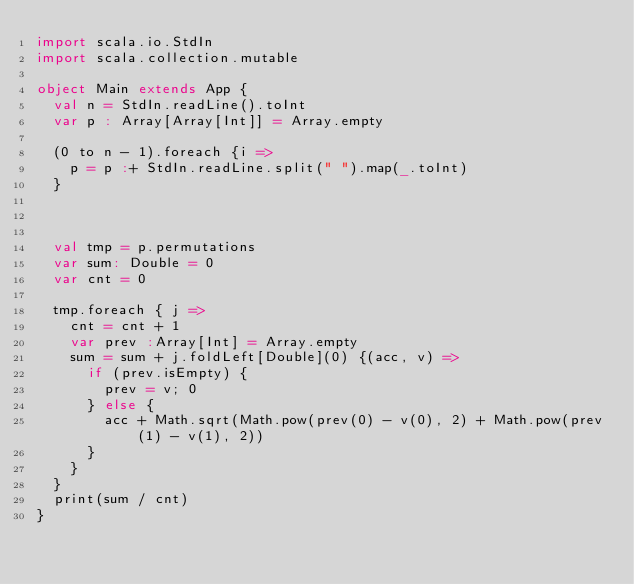<code> <loc_0><loc_0><loc_500><loc_500><_Scala_>import scala.io.StdIn
import scala.collection.mutable

object Main extends App {
  val n = StdIn.readLine().toInt
  var p : Array[Array[Int]] = Array.empty

  (0 to n - 1).foreach {i =>
    p = p :+ StdIn.readLine.split(" ").map(_.toInt)
  }

  

  val tmp = p.permutations
  var sum: Double = 0
  var cnt = 0

  tmp.foreach { j =>
    cnt = cnt + 1
    var prev :Array[Int] = Array.empty
    sum = sum + j.foldLeft[Double](0) {(acc, v) =>
      if (prev.isEmpty) {
        prev = v; 0
      } else {
        acc + Math.sqrt(Math.pow(prev(0) - v(0), 2) + Math.pow(prev(1) - v(1), 2))
      }
    }
  }
  print(sum / cnt)
}
</code> 